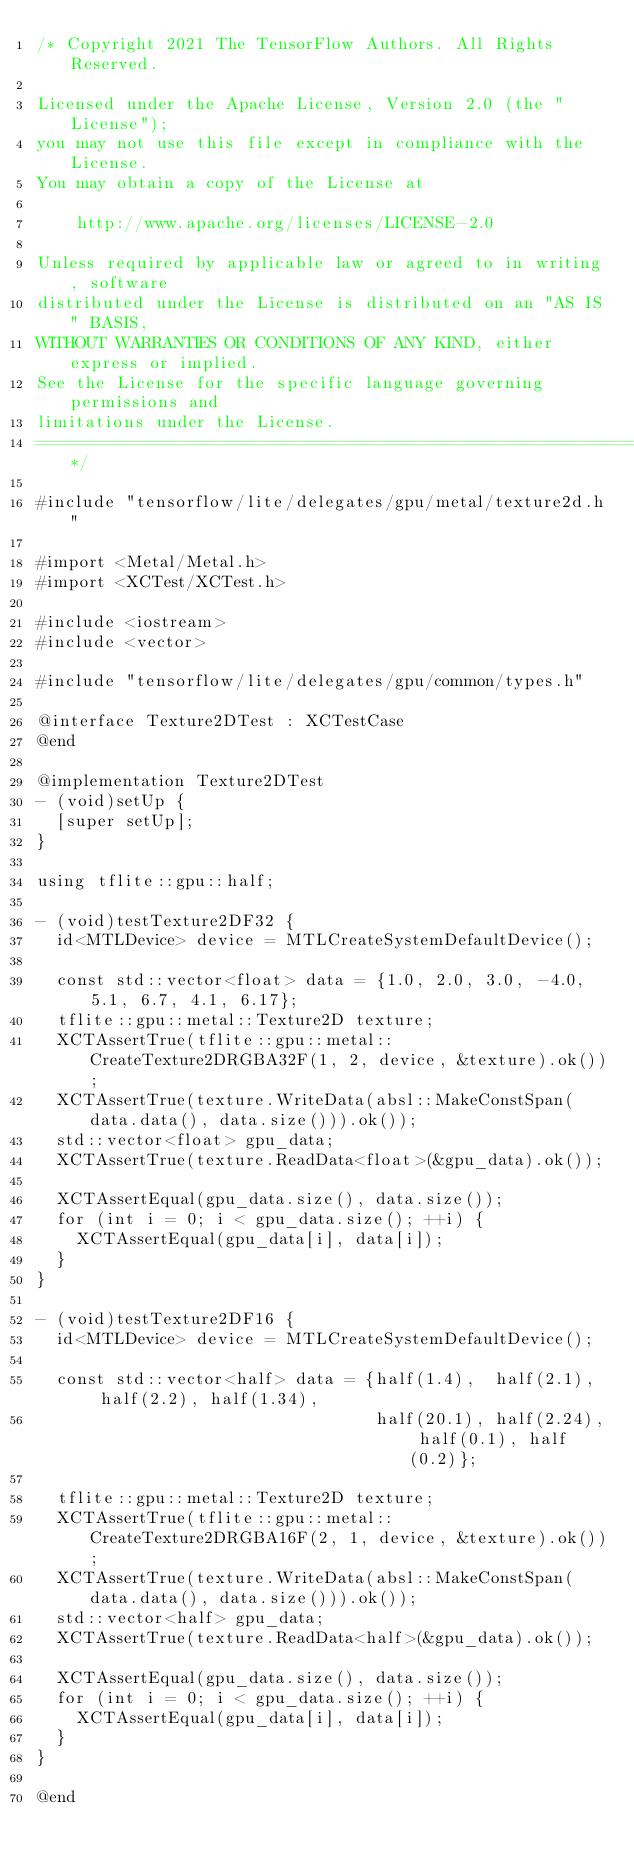<code> <loc_0><loc_0><loc_500><loc_500><_ObjectiveC_>/* Copyright 2021 The TensorFlow Authors. All Rights Reserved.

Licensed under the Apache License, Version 2.0 (the "License");
you may not use this file except in compliance with the License.
You may obtain a copy of the License at

    http://www.apache.org/licenses/LICENSE-2.0

Unless required by applicable law or agreed to in writing, software
distributed under the License is distributed on an "AS IS" BASIS,
WITHOUT WARRANTIES OR CONDITIONS OF ANY KIND, either express or implied.
See the License for the specific language governing permissions and
limitations under the License.
==============================================================================*/

#include "tensorflow/lite/delegates/gpu/metal/texture2d.h"

#import <Metal/Metal.h>
#import <XCTest/XCTest.h>

#include <iostream>
#include <vector>

#include "tensorflow/lite/delegates/gpu/common/types.h"

@interface Texture2DTest : XCTestCase
@end

@implementation Texture2DTest
- (void)setUp {
  [super setUp];
}

using tflite::gpu::half;

- (void)testTexture2DF32 {
  id<MTLDevice> device = MTLCreateSystemDefaultDevice();

  const std::vector<float> data = {1.0, 2.0, 3.0, -4.0, 5.1, 6.7, 4.1, 6.17};
  tflite::gpu::metal::Texture2D texture;
  XCTAssertTrue(tflite::gpu::metal::CreateTexture2DRGBA32F(1, 2, device, &texture).ok());
  XCTAssertTrue(texture.WriteData(absl::MakeConstSpan(data.data(), data.size())).ok());
  std::vector<float> gpu_data;
  XCTAssertTrue(texture.ReadData<float>(&gpu_data).ok());

  XCTAssertEqual(gpu_data.size(), data.size());
  for (int i = 0; i < gpu_data.size(); ++i) {
    XCTAssertEqual(gpu_data[i], data[i]);
  }
}

- (void)testTexture2DF16 {
  id<MTLDevice> device = MTLCreateSystemDefaultDevice();

  const std::vector<half> data = {half(1.4),  half(2.1),  half(2.2), half(1.34),
                                  half(20.1), half(2.24), half(0.1), half(0.2)};

  tflite::gpu::metal::Texture2D texture;
  XCTAssertTrue(tflite::gpu::metal::CreateTexture2DRGBA16F(2, 1, device, &texture).ok());
  XCTAssertTrue(texture.WriteData(absl::MakeConstSpan(data.data(), data.size())).ok());
  std::vector<half> gpu_data;
  XCTAssertTrue(texture.ReadData<half>(&gpu_data).ok());

  XCTAssertEqual(gpu_data.size(), data.size());
  for (int i = 0; i < gpu_data.size(); ++i) {
    XCTAssertEqual(gpu_data[i], data[i]);
  }
}

@end
</code> 